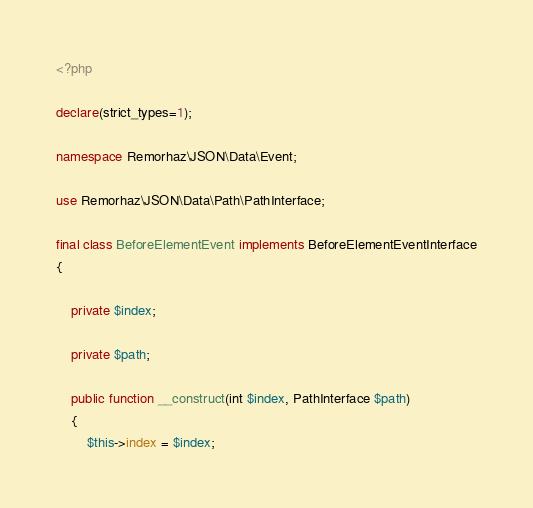Convert code to text. <code><loc_0><loc_0><loc_500><loc_500><_PHP_><?php

declare(strict_types=1);

namespace Remorhaz\JSON\Data\Event;

use Remorhaz\JSON\Data\Path\PathInterface;

final class BeforeElementEvent implements BeforeElementEventInterface
{

    private $index;

    private $path;

    public function __construct(int $index, PathInterface $path)
    {
        $this->index = $index;</code> 